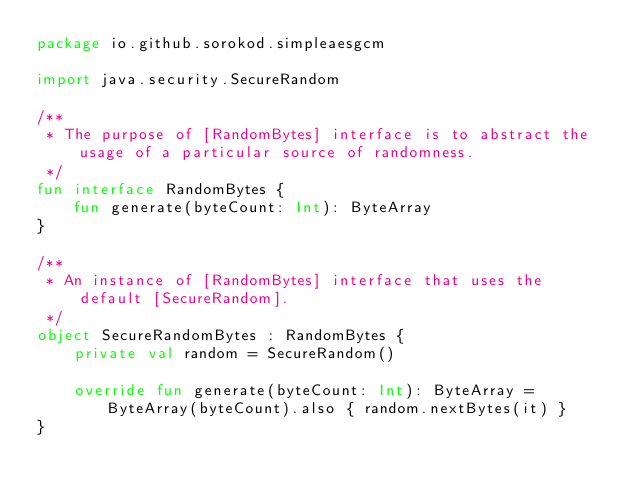<code> <loc_0><loc_0><loc_500><loc_500><_Kotlin_>package io.github.sorokod.simpleaesgcm

import java.security.SecureRandom

/**
 * The purpose of [RandomBytes] interface is to abstract the usage of a particular source of randomness.
 */
fun interface RandomBytes {
    fun generate(byteCount: Int): ByteArray
}

/**
 * An instance of [RandomBytes] interface that uses the default [SecureRandom].
 */
object SecureRandomBytes : RandomBytes {
    private val random = SecureRandom()

    override fun generate(byteCount: Int): ByteArray = ByteArray(byteCount).also { random.nextBytes(it) }
}</code> 